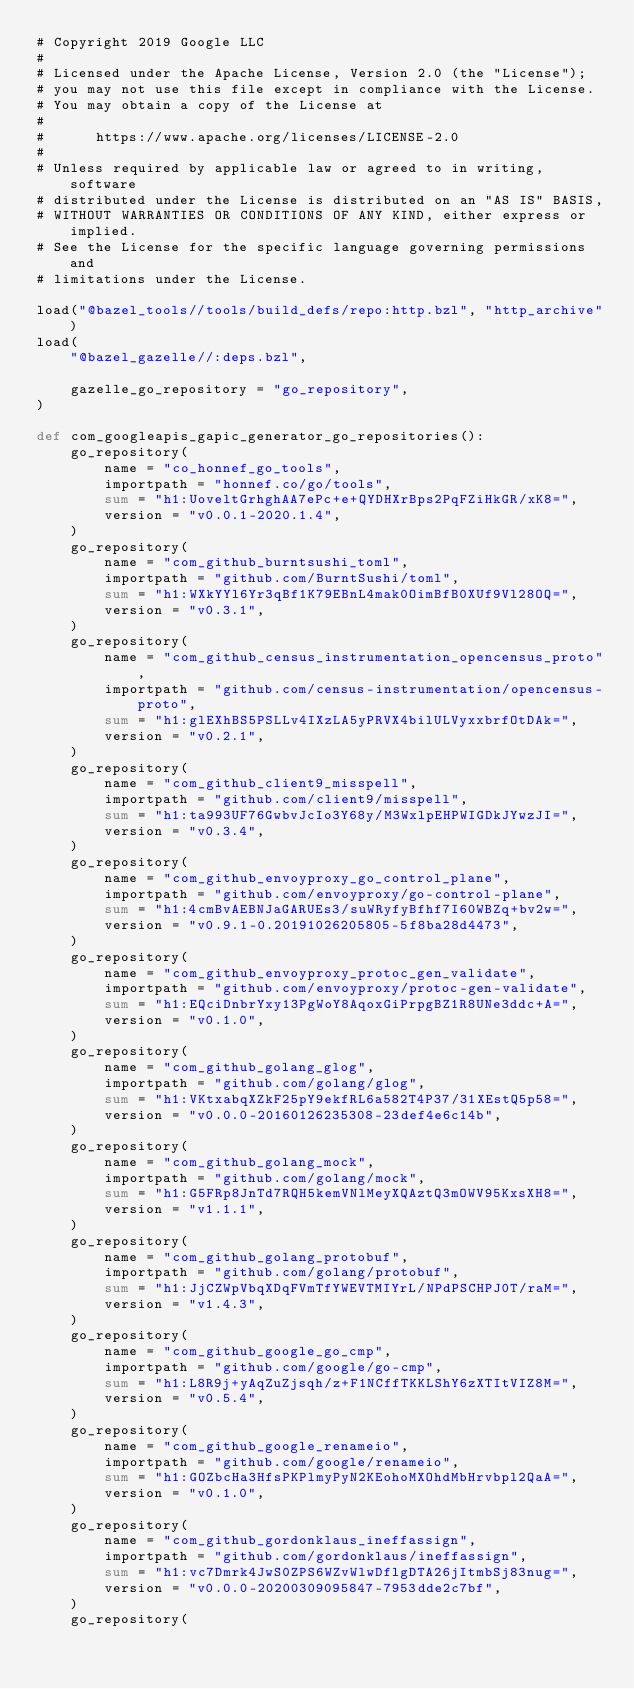Convert code to text. <code><loc_0><loc_0><loc_500><loc_500><_Python_># Copyright 2019 Google LLC
#
# Licensed under the Apache License, Version 2.0 (the "License");
# you may not use this file except in compliance with the License.
# You may obtain a copy of the License at
#
#      https://www.apache.org/licenses/LICENSE-2.0
#
# Unless required by applicable law or agreed to in writing, software
# distributed under the License is distributed on an "AS IS" BASIS,
# WITHOUT WARRANTIES OR CONDITIONS OF ANY KIND, either express or implied.
# See the License for the specific language governing permissions and
# limitations under the License.

load("@bazel_tools//tools/build_defs/repo:http.bzl", "http_archive")
load(
    "@bazel_gazelle//:deps.bzl",

    gazelle_go_repository = "go_repository",
)

def com_googleapis_gapic_generator_go_repositories():
    go_repository(
        name = "co_honnef_go_tools",
        importpath = "honnef.co/go/tools",
        sum = "h1:UoveltGrhghAA7ePc+e+QYDHXrBps2PqFZiHkGR/xK8=",
        version = "v0.0.1-2020.1.4",
    )
    go_repository(
        name = "com_github_burntsushi_toml",
        importpath = "github.com/BurntSushi/toml",
        sum = "h1:WXkYYl6Yr3qBf1K79EBnL4mak0OimBfB0XUf9Vl28OQ=",
        version = "v0.3.1",
    )
    go_repository(
        name = "com_github_census_instrumentation_opencensus_proto",
        importpath = "github.com/census-instrumentation/opencensus-proto",
        sum = "h1:glEXhBS5PSLLv4IXzLA5yPRVX4bilULVyxxbrfOtDAk=",
        version = "v0.2.1",
    )
    go_repository(
        name = "com_github_client9_misspell",
        importpath = "github.com/client9/misspell",
        sum = "h1:ta993UF76GwbvJcIo3Y68y/M3WxlpEHPWIGDkJYwzJI=",
        version = "v0.3.4",
    )
    go_repository(
        name = "com_github_envoyproxy_go_control_plane",
        importpath = "github.com/envoyproxy/go-control-plane",
        sum = "h1:4cmBvAEBNJaGARUEs3/suWRyfyBfhf7I60WBZq+bv2w=",
        version = "v0.9.1-0.20191026205805-5f8ba28d4473",
    )
    go_repository(
        name = "com_github_envoyproxy_protoc_gen_validate",
        importpath = "github.com/envoyproxy/protoc-gen-validate",
        sum = "h1:EQciDnbrYxy13PgWoY8AqoxGiPrpgBZ1R8UNe3ddc+A=",
        version = "v0.1.0",
    )
    go_repository(
        name = "com_github_golang_glog",
        importpath = "github.com/golang/glog",
        sum = "h1:VKtxabqXZkF25pY9ekfRL6a582T4P37/31XEstQ5p58=",
        version = "v0.0.0-20160126235308-23def4e6c14b",
    )
    go_repository(
        name = "com_github_golang_mock",
        importpath = "github.com/golang/mock",
        sum = "h1:G5FRp8JnTd7RQH5kemVNlMeyXQAztQ3mOWV95KxsXH8=",
        version = "v1.1.1",
    )
    go_repository(
        name = "com_github_golang_protobuf",
        importpath = "github.com/golang/protobuf",
        sum = "h1:JjCZWpVbqXDqFVmTfYWEVTMIYrL/NPdPSCHPJ0T/raM=",
        version = "v1.4.3",
    )
    go_repository(
        name = "com_github_google_go_cmp",
        importpath = "github.com/google/go-cmp",
        sum = "h1:L8R9j+yAqZuZjsqh/z+F1NCffTKKLShY6zXTItVIZ8M=",
        version = "v0.5.4",
    )
    go_repository(
        name = "com_github_google_renameio",
        importpath = "github.com/google/renameio",
        sum = "h1:GOZbcHa3HfsPKPlmyPyN2KEohoMXOhdMbHrvbpl2QaA=",
        version = "v0.1.0",
    )
    go_repository(
        name = "com_github_gordonklaus_ineffassign",
        importpath = "github.com/gordonklaus/ineffassign",
        sum = "h1:vc7Dmrk4JwS0ZPS6WZvWlwDflgDTA26jItmbSj83nug=",
        version = "v0.0.0-20200309095847-7953dde2c7bf",
    )
    go_repository(</code> 